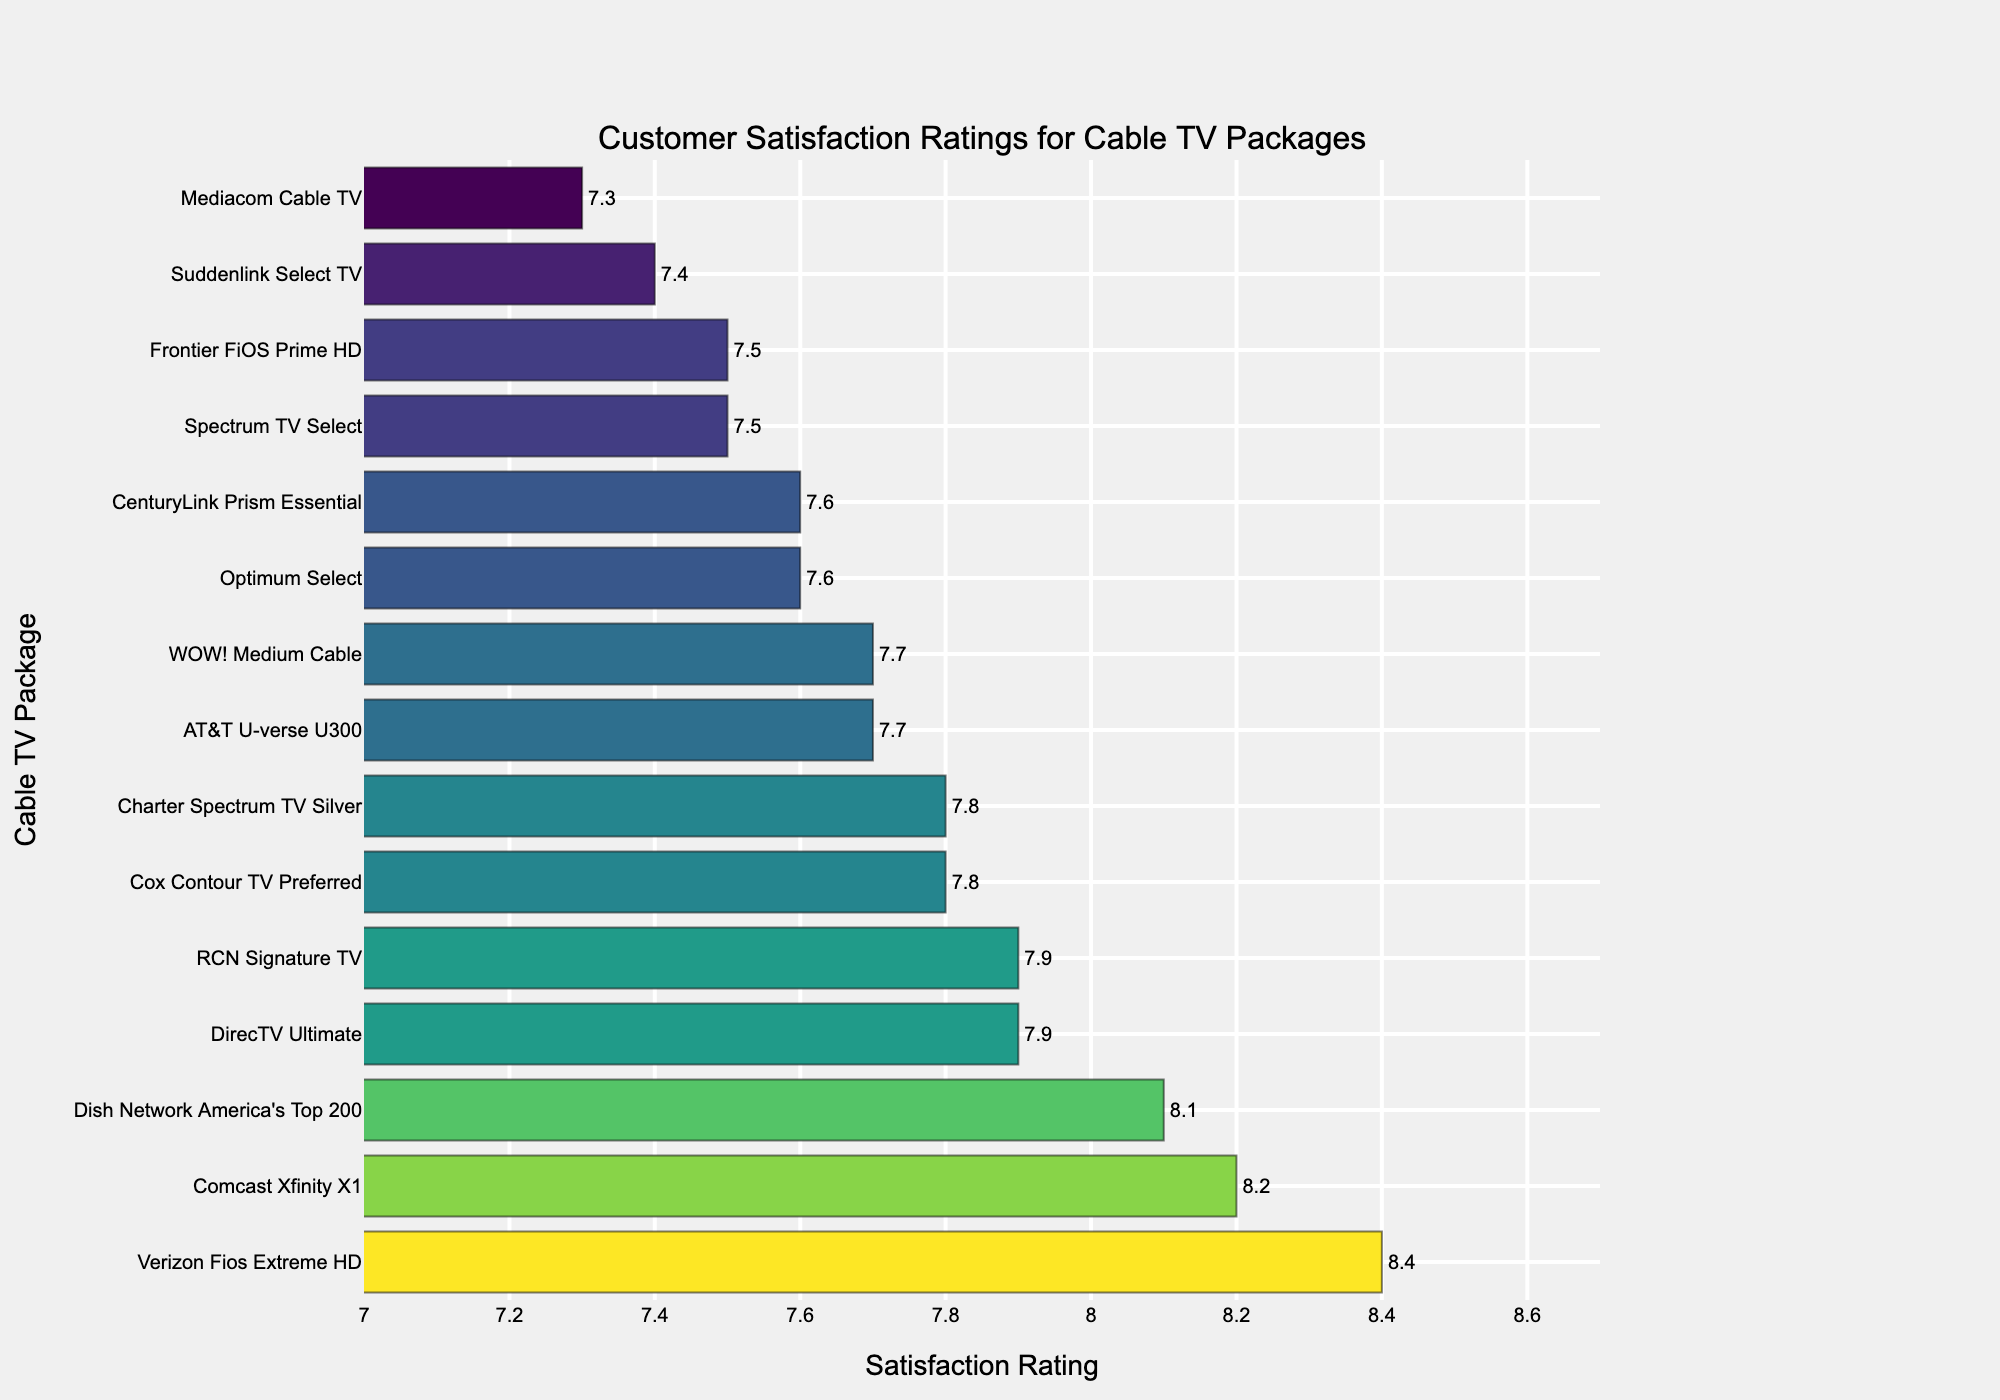Which cable TV package has the highest customer satisfaction rating? Look at the bar lengths and labels to identify the package with the highest numerical value.
Answer: Verizon Fios Extreme HD What is the difference in satisfaction rating between Comcast Xfinity X1 and Spectrum TV Select? Look at the ratings for Comcast Xfinity X1 (8.2) and Spectrum TV Select (7.5) and subtract the smaller one from the larger. 8.2 - 7.5 = 0.7
Answer: 0.7 Which packages have a satisfaction rating greater than 8.0? Identify all packages with ratings above 8.0 by checking the height of the bars and correlating with their respective labels.
Answer: Comcast Xfinity X1, Dish Network America's Top 200, Verizon Fios Extreme HD How many cable TV packages have a satisfaction rating less than 7.5? Count all the bars with values less than 7.5 by checking each label and its corresponding rating.
Answer: 2 What is the average satisfaction rating for the top three highest-rated packages? First, identify the top three highest-rated packages. Then add their ratings and divide by 3. (8.4 + 8.2 + 8.1) / 3 = 8.23
Answer: 8.23 Which package has a higher satisfaction rating: AT&T U-verse U300 or Cox Contour TV Preferred? Look at the ratings of both packages. AT&T U-verse U300 has a rating of 7.7, while Cox Contour TV Preferred has a rating of 7.8.
Answer: Cox Contour TV Preferred What is the combined satisfaction rating of the packages rated exactly 7.9? Identify and add the ratings of all packages with exactly 7.9. There are two: DirecTV Ultimate and RCN Signature TV. 7.9 + 7.9 = 15.8
Answer: 15.8 Which package's bar is closest to the average satisfaction rating of all packages? Calculate the average satisfaction rating of all packages, and then identify the bar closest to this average. Sum all ratings and divide by the number of packages: (8.2 + 7.9 + 7.5 + 8.1 + 7.7 + 8.4 + 7.8 + 7.6 + 7.3 + 7.9 + 7.5 + 7.7 + 7.4 + 7.8 + 7.6) / 15 ≈ 7.76. The closest is AT&T U-verse U300 with a 7.7 rating.
Answer: AT&T U-verse U300 Which has a longer bar, RCN Signature TV or CenturyLink Prism Essential? Compare the visual length of the bars for these two packages. RCN Signature TV has a rating of 7.9, and CenturyLink Prism Essential has a rating of 7.6, so RCN Signature TV has the longer bar.
Answer: RCN Signature TV How much higher is the satisfaction rating for Verizon Fios Extreme HD compared to Mediacom Cable TV? Find the ratings for both packages and subtract Mediacom Cable TV's rating from Verizon Fios Extreme HD's rating. 8.4 - 7.3 = 1.1
Answer: 1.1 